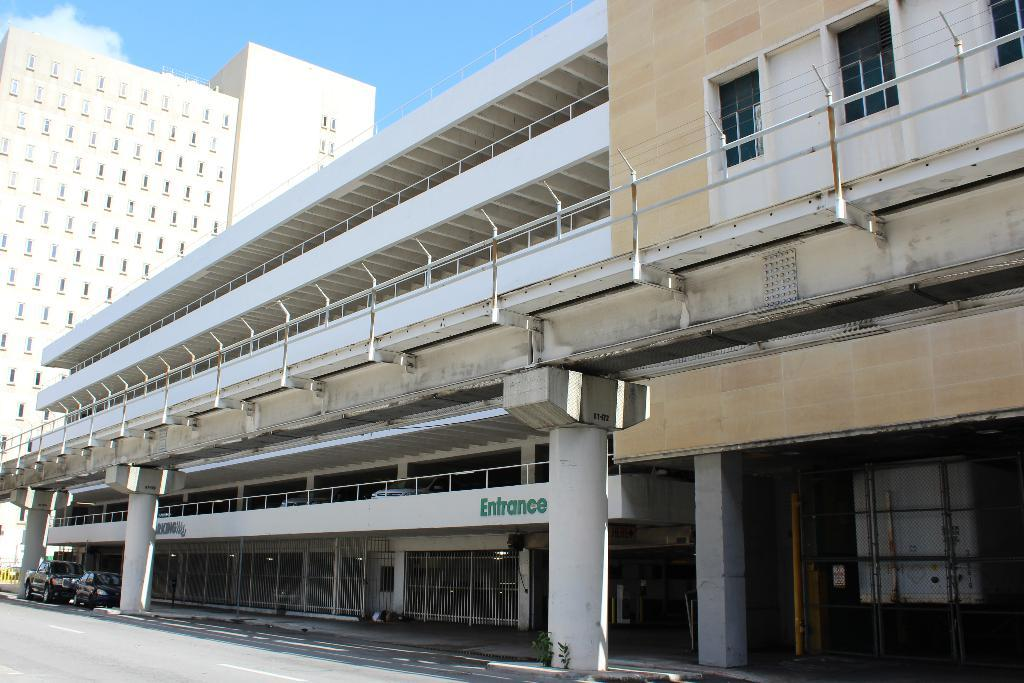What type of structures can be seen in the image? There are buildings in the image. What else can be seen on the ground in the image? Cars are visible on the road at the bottom of the image. What is visible in the background of the image? There is sky visible in the background of the image. What type of pear is being used to write on the buildings in the image? There is no pear present in the image, and the buildings are not being written on. 